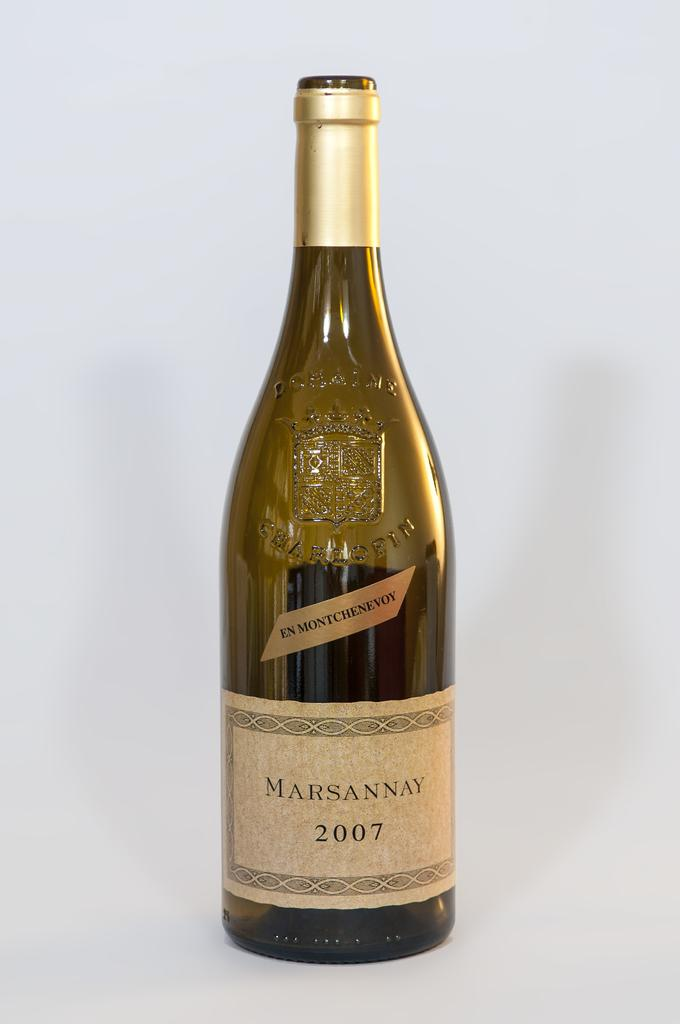<image>
Relay a brief, clear account of the picture shown. A bottle of 2007 Marsannay is empty, with no cork or cap. 